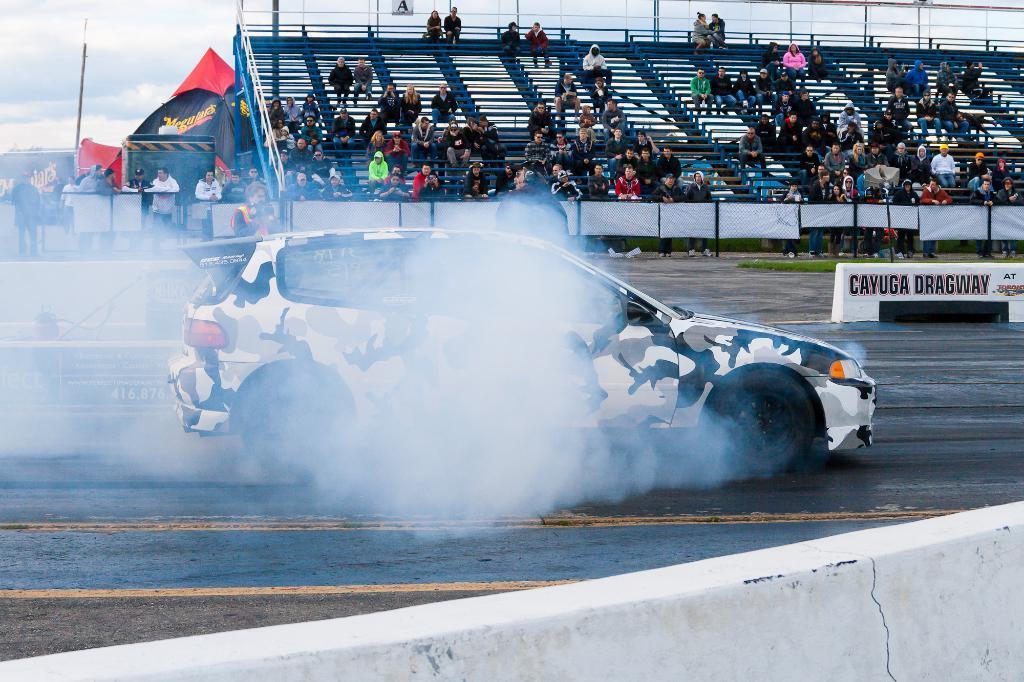How would you summarize this image in a sentence or two? In this image we can see car on the road and smoke is coming out from the car. Background of the image we can see so many people are sitting on the benches and banners are there. We can see one tent and pole in the top left corner of the image. At the top of the image we can see the sky covered with cloud. At the bottom of the image white color wall is there. 